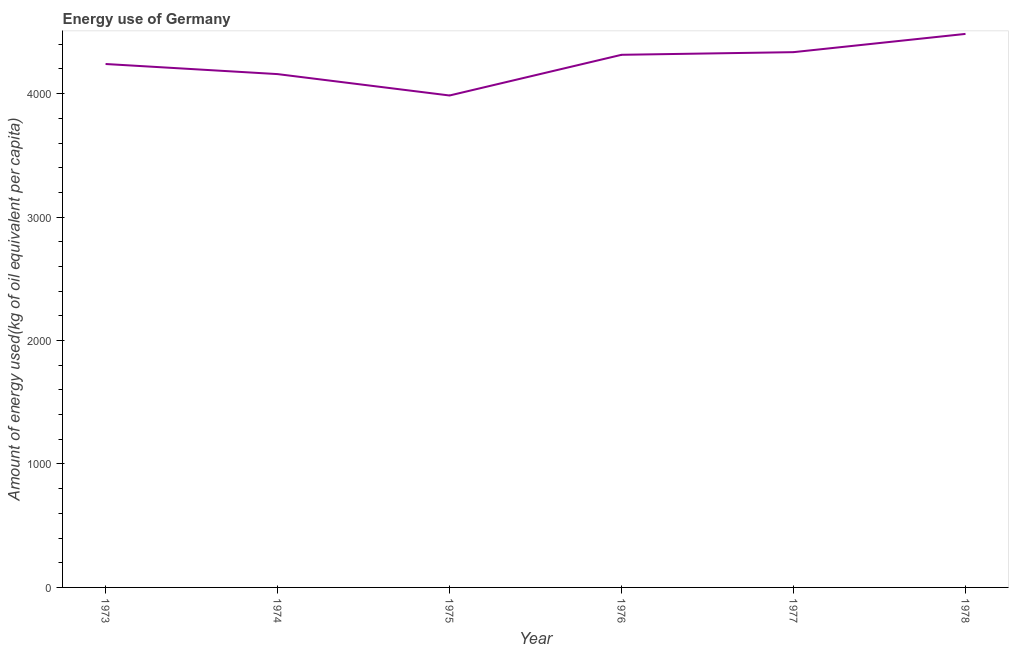What is the amount of energy used in 1978?
Ensure brevity in your answer.  4483.88. Across all years, what is the maximum amount of energy used?
Provide a succinct answer. 4483.88. Across all years, what is the minimum amount of energy used?
Provide a succinct answer. 3984.97. In which year was the amount of energy used maximum?
Keep it short and to the point. 1978. In which year was the amount of energy used minimum?
Give a very brief answer. 1975. What is the sum of the amount of energy used?
Your answer should be very brief. 2.55e+04. What is the difference between the amount of energy used in 1975 and 1977?
Give a very brief answer. -351.11. What is the average amount of energy used per year?
Provide a short and direct response. 4252.98. What is the median amount of energy used?
Your response must be concise. 4277.32. Do a majority of the years between 1974 and 1973 (inclusive) have amount of energy used greater than 3600 kg?
Ensure brevity in your answer.  No. What is the ratio of the amount of energy used in 1976 to that in 1977?
Make the answer very short. 1. Is the difference between the amount of energy used in 1973 and 1978 greater than the difference between any two years?
Offer a terse response. No. What is the difference between the highest and the second highest amount of energy used?
Make the answer very short. 147.79. Is the sum of the amount of energy used in 1977 and 1978 greater than the maximum amount of energy used across all years?
Your answer should be compact. Yes. What is the difference between the highest and the lowest amount of energy used?
Give a very brief answer. 498.91. How many years are there in the graph?
Offer a terse response. 6. Does the graph contain any zero values?
Your response must be concise. No. Does the graph contain grids?
Keep it short and to the point. No. What is the title of the graph?
Give a very brief answer. Energy use of Germany. What is the label or title of the X-axis?
Ensure brevity in your answer.  Year. What is the label or title of the Y-axis?
Ensure brevity in your answer.  Amount of energy used(kg of oil equivalent per capita). What is the Amount of energy used(kg of oil equivalent per capita) of 1973?
Keep it short and to the point. 4240.06. What is the Amount of energy used(kg of oil equivalent per capita) in 1974?
Your answer should be very brief. 4158.27. What is the Amount of energy used(kg of oil equivalent per capita) in 1975?
Ensure brevity in your answer.  3984.97. What is the Amount of energy used(kg of oil equivalent per capita) of 1976?
Offer a terse response. 4314.58. What is the Amount of energy used(kg of oil equivalent per capita) in 1977?
Make the answer very short. 4336.09. What is the Amount of energy used(kg of oil equivalent per capita) of 1978?
Offer a very short reply. 4483.88. What is the difference between the Amount of energy used(kg of oil equivalent per capita) in 1973 and 1974?
Keep it short and to the point. 81.79. What is the difference between the Amount of energy used(kg of oil equivalent per capita) in 1973 and 1975?
Make the answer very short. 255.09. What is the difference between the Amount of energy used(kg of oil equivalent per capita) in 1973 and 1976?
Your answer should be compact. -74.52. What is the difference between the Amount of energy used(kg of oil equivalent per capita) in 1973 and 1977?
Provide a short and direct response. -96.03. What is the difference between the Amount of energy used(kg of oil equivalent per capita) in 1973 and 1978?
Offer a very short reply. -243.82. What is the difference between the Amount of energy used(kg of oil equivalent per capita) in 1974 and 1975?
Ensure brevity in your answer.  173.3. What is the difference between the Amount of energy used(kg of oil equivalent per capita) in 1974 and 1976?
Offer a terse response. -156.31. What is the difference between the Amount of energy used(kg of oil equivalent per capita) in 1974 and 1977?
Your response must be concise. -177.82. What is the difference between the Amount of energy used(kg of oil equivalent per capita) in 1974 and 1978?
Your response must be concise. -325.61. What is the difference between the Amount of energy used(kg of oil equivalent per capita) in 1975 and 1976?
Your answer should be very brief. -329.61. What is the difference between the Amount of energy used(kg of oil equivalent per capita) in 1975 and 1977?
Make the answer very short. -351.11. What is the difference between the Amount of energy used(kg of oil equivalent per capita) in 1975 and 1978?
Your response must be concise. -498.91. What is the difference between the Amount of energy used(kg of oil equivalent per capita) in 1976 and 1977?
Offer a very short reply. -21.51. What is the difference between the Amount of energy used(kg of oil equivalent per capita) in 1976 and 1978?
Ensure brevity in your answer.  -169.3. What is the difference between the Amount of energy used(kg of oil equivalent per capita) in 1977 and 1978?
Keep it short and to the point. -147.79. What is the ratio of the Amount of energy used(kg of oil equivalent per capita) in 1973 to that in 1975?
Provide a short and direct response. 1.06. What is the ratio of the Amount of energy used(kg of oil equivalent per capita) in 1973 to that in 1977?
Your answer should be very brief. 0.98. What is the ratio of the Amount of energy used(kg of oil equivalent per capita) in 1973 to that in 1978?
Ensure brevity in your answer.  0.95. What is the ratio of the Amount of energy used(kg of oil equivalent per capita) in 1974 to that in 1975?
Offer a very short reply. 1.04. What is the ratio of the Amount of energy used(kg of oil equivalent per capita) in 1974 to that in 1978?
Ensure brevity in your answer.  0.93. What is the ratio of the Amount of energy used(kg of oil equivalent per capita) in 1975 to that in 1976?
Offer a very short reply. 0.92. What is the ratio of the Amount of energy used(kg of oil equivalent per capita) in 1975 to that in 1977?
Offer a very short reply. 0.92. What is the ratio of the Amount of energy used(kg of oil equivalent per capita) in 1975 to that in 1978?
Offer a very short reply. 0.89. What is the ratio of the Amount of energy used(kg of oil equivalent per capita) in 1977 to that in 1978?
Offer a terse response. 0.97. 